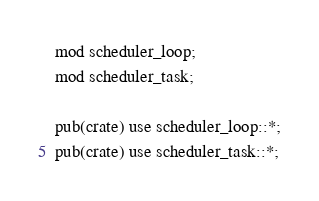Convert code to text. <code><loc_0><loc_0><loc_500><loc_500><_Rust_>mod scheduler_loop;
mod scheduler_task;

pub(crate) use scheduler_loop::*;
pub(crate) use scheduler_task::*;
</code> 